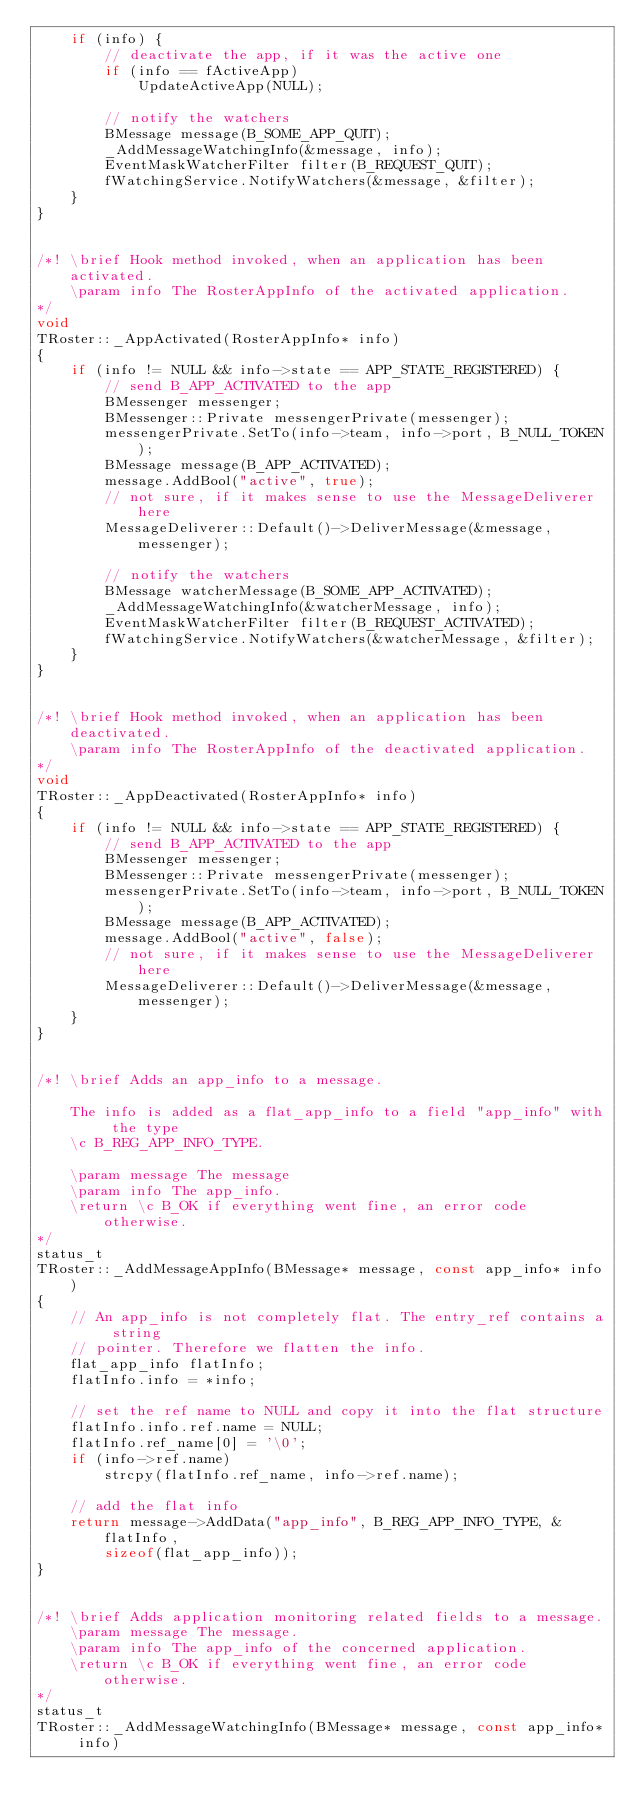<code> <loc_0><loc_0><loc_500><loc_500><_C++_>	if (info) {
		// deactivate the app, if it was the active one
		if (info == fActiveApp)
			UpdateActiveApp(NULL);

		// notify the watchers
		BMessage message(B_SOME_APP_QUIT);
		_AddMessageWatchingInfo(&message, info);
		EventMaskWatcherFilter filter(B_REQUEST_QUIT);
		fWatchingService.NotifyWatchers(&message, &filter);
	}
}


/*!	\brief Hook method invoked, when an application has been activated.
	\param info The RosterAppInfo of the activated application.
*/
void
TRoster::_AppActivated(RosterAppInfo* info)
{
	if (info != NULL && info->state == APP_STATE_REGISTERED) {
		// send B_APP_ACTIVATED to the app
		BMessenger messenger;
		BMessenger::Private messengerPrivate(messenger);
		messengerPrivate.SetTo(info->team, info->port, B_NULL_TOKEN);
		BMessage message(B_APP_ACTIVATED);
		message.AddBool("active", true);
		// not sure, if it makes sense to use the MessageDeliverer here
		MessageDeliverer::Default()->DeliverMessage(&message, messenger);

		// notify the watchers
		BMessage watcherMessage(B_SOME_APP_ACTIVATED);
		_AddMessageWatchingInfo(&watcherMessage, info);
		EventMaskWatcherFilter filter(B_REQUEST_ACTIVATED);
		fWatchingService.NotifyWatchers(&watcherMessage, &filter);
	}
}


/*!	\brief Hook method invoked, when an application has been deactivated.
	\param info The RosterAppInfo of the deactivated application.
*/
void
TRoster::_AppDeactivated(RosterAppInfo* info)
{
	if (info != NULL && info->state == APP_STATE_REGISTERED) {
		// send B_APP_ACTIVATED to the app
		BMessenger messenger;
		BMessenger::Private messengerPrivate(messenger);
		messengerPrivate.SetTo(info->team, info->port, B_NULL_TOKEN);
		BMessage message(B_APP_ACTIVATED);
		message.AddBool("active", false);
		// not sure, if it makes sense to use the MessageDeliverer here
		MessageDeliverer::Default()->DeliverMessage(&message, messenger);
	}
}


/*!	\brief Adds an app_info to a message.

	The info is added as a flat_app_info to a field "app_info" with the type
	\c B_REG_APP_INFO_TYPE.

	\param message The message
	\param info The app_info.
	\return \c B_OK if everything went fine, an error code otherwise.
*/
status_t
TRoster::_AddMessageAppInfo(BMessage* message, const app_info* info)
{
	// An app_info is not completely flat. The entry_ref contains a string
	// pointer. Therefore we flatten the info.
	flat_app_info flatInfo;
	flatInfo.info = *info;

	// set the ref name to NULL and copy it into the flat structure
	flatInfo.info.ref.name = NULL;
	flatInfo.ref_name[0] = '\0';
	if (info->ref.name)
		strcpy(flatInfo.ref_name, info->ref.name);

	// add the flat info
	return message->AddData("app_info", B_REG_APP_INFO_TYPE, &flatInfo,
		sizeof(flat_app_info));
}


/*!	\brief Adds application monitoring related fields to a message.
	\param message The message.
	\param info The app_info of the concerned application.
	\return \c B_OK if everything went fine, an error code otherwise.
*/
status_t
TRoster::_AddMessageWatchingInfo(BMessage* message, const app_info* info)</code> 